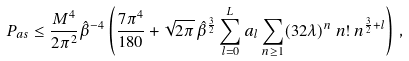<formula> <loc_0><loc_0><loc_500><loc_500>P _ { a s } \leq \frac { M ^ { 4 } } { 2 \pi ^ { 2 } } { \hat { \beta } } ^ { - 4 } \left ( \frac { 7 \pi ^ { 4 } } { 1 8 0 } + \sqrt { 2 \pi } \, { \hat { \beta } } ^ { \frac { 3 } { 2 } } \sum ^ { L } _ { l = 0 } a _ { l } \sum _ { n \geq 1 } ( 3 2 \lambda ) ^ { n } \, n ! \, n ^ { \frac { 3 } { 2 } + l } \right ) \, ,</formula> 